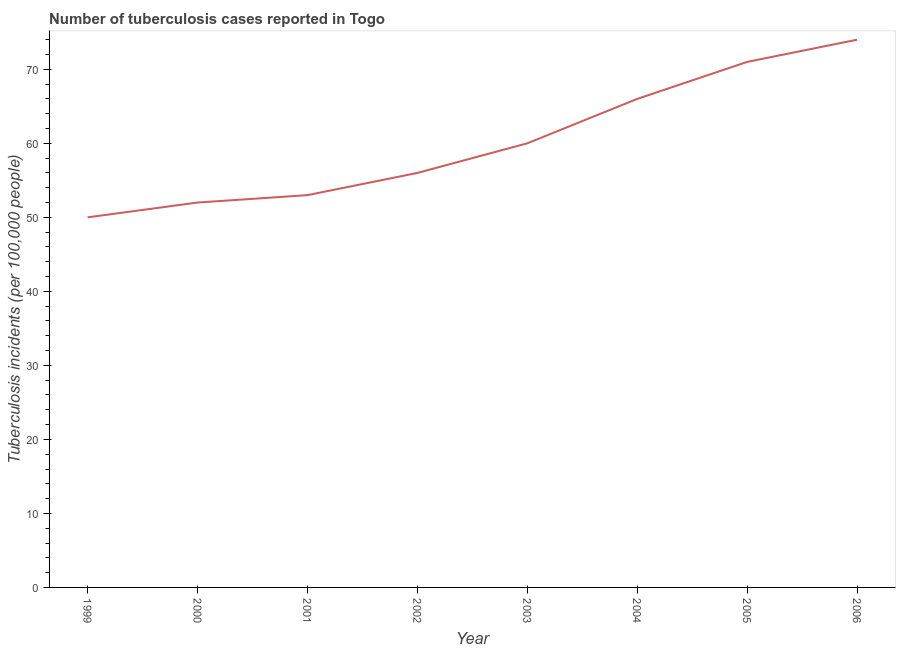What is the number of tuberculosis incidents in 1999?
Your response must be concise. 50. Across all years, what is the maximum number of tuberculosis incidents?
Offer a terse response. 74. Across all years, what is the minimum number of tuberculosis incidents?
Make the answer very short. 50. What is the sum of the number of tuberculosis incidents?
Offer a very short reply. 482. What is the difference between the number of tuberculosis incidents in 2002 and 2003?
Offer a very short reply. -4. What is the average number of tuberculosis incidents per year?
Provide a succinct answer. 60.25. What is the median number of tuberculosis incidents?
Keep it short and to the point. 58. Do a majority of the years between 1999 and 2000 (inclusive) have number of tuberculosis incidents greater than 38 ?
Make the answer very short. Yes. What is the ratio of the number of tuberculosis incidents in 2000 to that in 2006?
Your response must be concise. 0.7. Is the number of tuberculosis incidents in 1999 less than that in 2006?
Keep it short and to the point. Yes. Is the sum of the number of tuberculosis incidents in 2001 and 2006 greater than the maximum number of tuberculosis incidents across all years?
Your answer should be very brief. Yes. What is the difference between the highest and the lowest number of tuberculosis incidents?
Give a very brief answer. 24. Does the number of tuberculosis incidents monotonically increase over the years?
Offer a terse response. Yes. What is the difference between two consecutive major ticks on the Y-axis?
Provide a succinct answer. 10. Does the graph contain any zero values?
Your answer should be compact. No. Does the graph contain grids?
Your response must be concise. No. What is the title of the graph?
Your response must be concise. Number of tuberculosis cases reported in Togo. What is the label or title of the X-axis?
Provide a short and direct response. Year. What is the label or title of the Y-axis?
Your answer should be compact. Tuberculosis incidents (per 100,0 people). What is the Tuberculosis incidents (per 100,000 people) in 1999?
Make the answer very short. 50. What is the Tuberculosis incidents (per 100,000 people) in 2001?
Give a very brief answer. 53. What is the Tuberculosis incidents (per 100,000 people) of 2003?
Make the answer very short. 60. What is the Tuberculosis incidents (per 100,000 people) in 2006?
Your answer should be very brief. 74. What is the difference between the Tuberculosis incidents (per 100,000 people) in 1999 and 2000?
Provide a short and direct response. -2. What is the difference between the Tuberculosis incidents (per 100,000 people) in 1999 and 2001?
Your answer should be very brief. -3. What is the difference between the Tuberculosis incidents (per 100,000 people) in 1999 and 2002?
Offer a very short reply. -6. What is the difference between the Tuberculosis incidents (per 100,000 people) in 1999 and 2004?
Give a very brief answer. -16. What is the difference between the Tuberculosis incidents (per 100,000 people) in 1999 and 2006?
Provide a succinct answer. -24. What is the difference between the Tuberculosis incidents (per 100,000 people) in 2000 and 2002?
Give a very brief answer. -4. What is the difference between the Tuberculosis incidents (per 100,000 people) in 2000 and 2003?
Keep it short and to the point. -8. What is the difference between the Tuberculosis incidents (per 100,000 people) in 2000 and 2006?
Your response must be concise. -22. What is the difference between the Tuberculosis incidents (per 100,000 people) in 2001 and 2003?
Your answer should be compact. -7. What is the difference between the Tuberculosis incidents (per 100,000 people) in 2001 and 2006?
Provide a succinct answer. -21. What is the difference between the Tuberculosis incidents (per 100,000 people) in 2002 and 2005?
Offer a very short reply. -15. What is the difference between the Tuberculosis incidents (per 100,000 people) in 2002 and 2006?
Provide a short and direct response. -18. What is the difference between the Tuberculosis incidents (per 100,000 people) in 2003 and 2004?
Offer a very short reply. -6. What is the difference between the Tuberculosis incidents (per 100,000 people) in 2004 and 2005?
Offer a terse response. -5. What is the difference between the Tuberculosis incidents (per 100,000 people) in 2004 and 2006?
Provide a short and direct response. -8. What is the difference between the Tuberculosis incidents (per 100,000 people) in 2005 and 2006?
Your response must be concise. -3. What is the ratio of the Tuberculosis incidents (per 100,000 people) in 1999 to that in 2001?
Provide a short and direct response. 0.94. What is the ratio of the Tuberculosis incidents (per 100,000 people) in 1999 to that in 2002?
Your response must be concise. 0.89. What is the ratio of the Tuberculosis incidents (per 100,000 people) in 1999 to that in 2003?
Offer a terse response. 0.83. What is the ratio of the Tuberculosis incidents (per 100,000 people) in 1999 to that in 2004?
Your response must be concise. 0.76. What is the ratio of the Tuberculosis incidents (per 100,000 people) in 1999 to that in 2005?
Make the answer very short. 0.7. What is the ratio of the Tuberculosis incidents (per 100,000 people) in 1999 to that in 2006?
Provide a short and direct response. 0.68. What is the ratio of the Tuberculosis incidents (per 100,000 people) in 2000 to that in 2002?
Give a very brief answer. 0.93. What is the ratio of the Tuberculosis incidents (per 100,000 people) in 2000 to that in 2003?
Your answer should be very brief. 0.87. What is the ratio of the Tuberculosis incidents (per 100,000 people) in 2000 to that in 2004?
Your response must be concise. 0.79. What is the ratio of the Tuberculosis incidents (per 100,000 people) in 2000 to that in 2005?
Ensure brevity in your answer.  0.73. What is the ratio of the Tuberculosis incidents (per 100,000 people) in 2000 to that in 2006?
Your answer should be compact. 0.7. What is the ratio of the Tuberculosis incidents (per 100,000 people) in 2001 to that in 2002?
Keep it short and to the point. 0.95. What is the ratio of the Tuberculosis incidents (per 100,000 people) in 2001 to that in 2003?
Give a very brief answer. 0.88. What is the ratio of the Tuberculosis incidents (per 100,000 people) in 2001 to that in 2004?
Keep it short and to the point. 0.8. What is the ratio of the Tuberculosis incidents (per 100,000 people) in 2001 to that in 2005?
Ensure brevity in your answer.  0.75. What is the ratio of the Tuberculosis incidents (per 100,000 people) in 2001 to that in 2006?
Offer a very short reply. 0.72. What is the ratio of the Tuberculosis incidents (per 100,000 people) in 2002 to that in 2003?
Ensure brevity in your answer.  0.93. What is the ratio of the Tuberculosis incidents (per 100,000 people) in 2002 to that in 2004?
Provide a succinct answer. 0.85. What is the ratio of the Tuberculosis incidents (per 100,000 people) in 2002 to that in 2005?
Make the answer very short. 0.79. What is the ratio of the Tuberculosis incidents (per 100,000 people) in 2002 to that in 2006?
Your answer should be very brief. 0.76. What is the ratio of the Tuberculosis incidents (per 100,000 people) in 2003 to that in 2004?
Provide a succinct answer. 0.91. What is the ratio of the Tuberculosis incidents (per 100,000 people) in 2003 to that in 2005?
Give a very brief answer. 0.84. What is the ratio of the Tuberculosis incidents (per 100,000 people) in 2003 to that in 2006?
Offer a terse response. 0.81. What is the ratio of the Tuberculosis incidents (per 100,000 people) in 2004 to that in 2006?
Offer a terse response. 0.89. What is the ratio of the Tuberculosis incidents (per 100,000 people) in 2005 to that in 2006?
Provide a short and direct response. 0.96. 